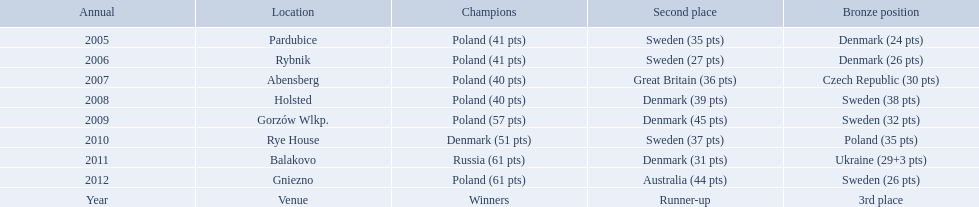After enjoying five consecutive victories at the team speedway junior world championship poland was finally unseated in what year? 2010. In that year, what teams placed first through third? Denmark (51 pts), Sweden (37 pts), Poland (35 pts). Which of those positions did poland specifically place in? 3rd place. 